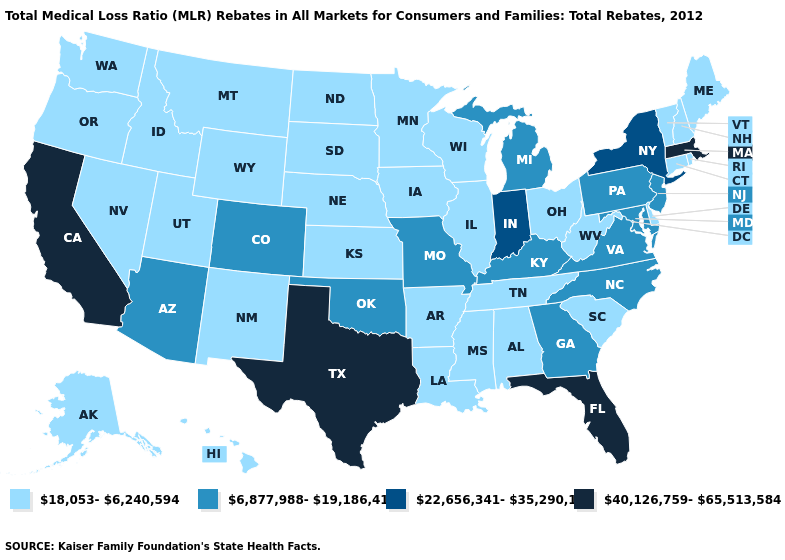What is the value of Maine?
Write a very short answer. 18,053-6,240,594. Does Maryland have the lowest value in the USA?
Answer briefly. No. What is the value of Kentucky?
Quick response, please. 6,877,988-19,186,416. Name the states that have a value in the range 6,877,988-19,186,416?
Be succinct. Arizona, Colorado, Georgia, Kentucky, Maryland, Michigan, Missouri, New Jersey, North Carolina, Oklahoma, Pennsylvania, Virginia. What is the value of Wisconsin?
Answer briefly. 18,053-6,240,594. Does Connecticut have the same value as Virginia?
Be succinct. No. Does the map have missing data?
Answer briefly. No. Is the legend a continuous bar?
Answer briefly. No. Is the legend a continuous bar?
Give a very brief answer. No. Does Kansas have the highest value in the MidWest?
Give a very brief answer. No. Does Oklahoma have the highest value in the USA?
Short answer required. No. What is the highest value in states that border Georgia?
Concise answer only. 40,126,759-65,513,584. What is the highest value in the South ?
Be succinct. 40,126,759-65,513,584. Among the states that border Texas , which have the lowest value?
Give a very brief answer. Arkansas, Louisiana, New Mexico. Among the states that border Wyoming , does Utah have the highest value?
Give a very brief answer. No. 